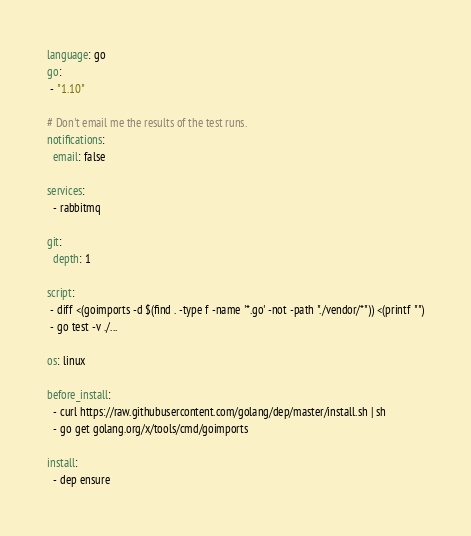Convert code to text. <code><loc_0><loc_0><loc_500><loc_500><_YAML_>language: go
go:
 - "1.10"

# Don't email me the results of the test runs.
notifications:
  email: false

services:
  - rabbitmq

git:
  depth: 1

script:
 - diff <(goimports -d $(find . -type f -name '*.go' -not -path "./vendor/*")) <(printf "")
 - go test -v ./...

os: linux

before_install:
  - curl https://raw.githubusercontent.com/golang/dep/master/install.sh | sh
  - go get golang.org/x/tools/cmd/goimports

install:
  - dep ensure
</code> 